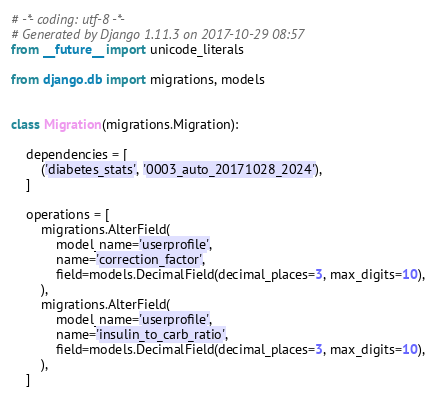Convert code to text. <code><loc_0><loc_0><loc_500><loc_500><_Python_># -*- coding: utf-8 -*-
# Generated by Django 1.11.3 on 2017-10-29 08:57
from __future__ import unicode_literals

from django.db import migrations, models


class Migration(migrations.Migration):

    dependencies = [
        ('diabetes_stats', '0003_auto_20171028_2024'),
    ]

    operations = [
        migrations.AlterField(
            model_name='userprofile',
            name='correction_factor',
            field=models.DecimalField(decimal_places=3, max_digits=10),
        ),
        migrations.AlterField(
            model_name='userprofile',
            name='insulin_to_carb_ratio',
            field=models.DecimalField(decimal_places=3, max_digits=10),
        ),
    ]
</code> 